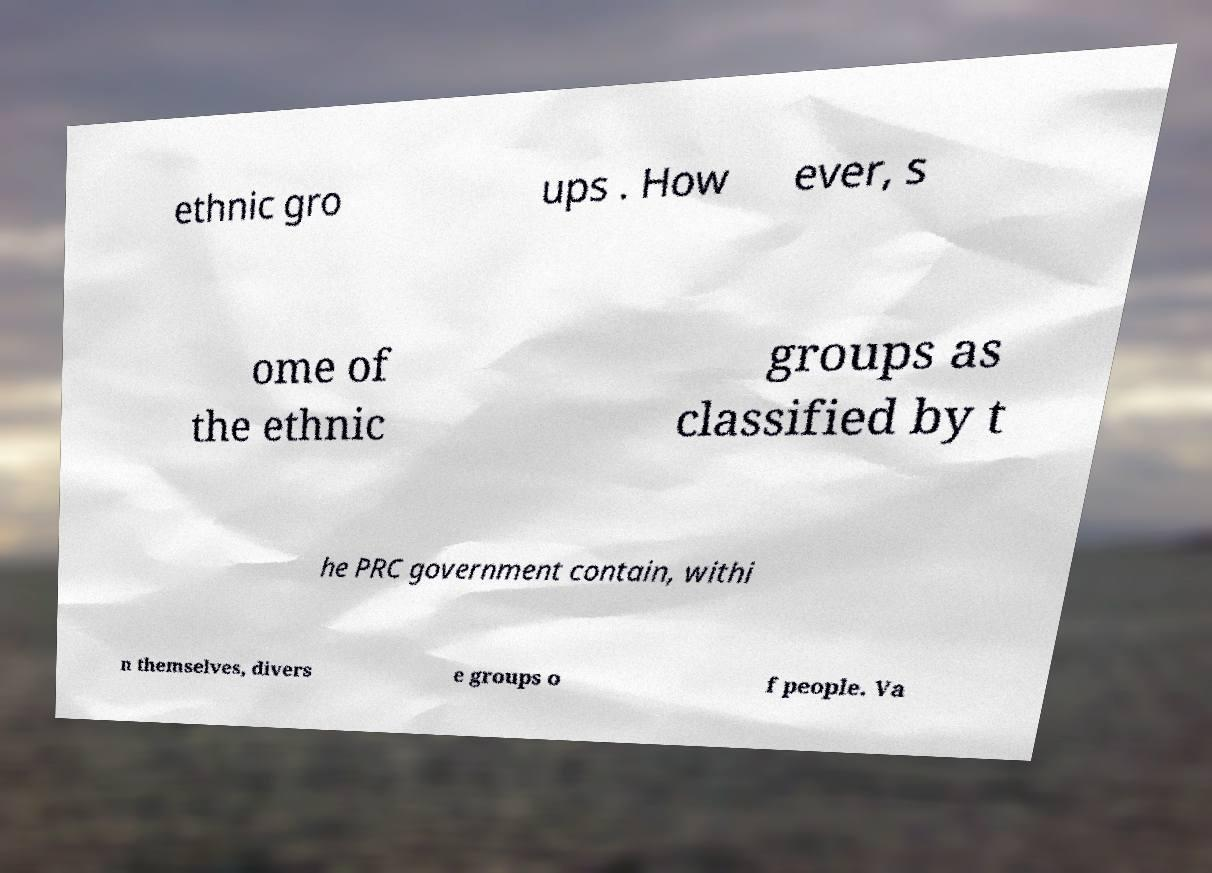There's text embedded in this image that I need extracted. Can you transcribe it verbatim? ethnic gro ups . How ever, s ome of the ethnic groups as classified by t he PRC government contain, withi n themselves, divers e groups o f people. Va 